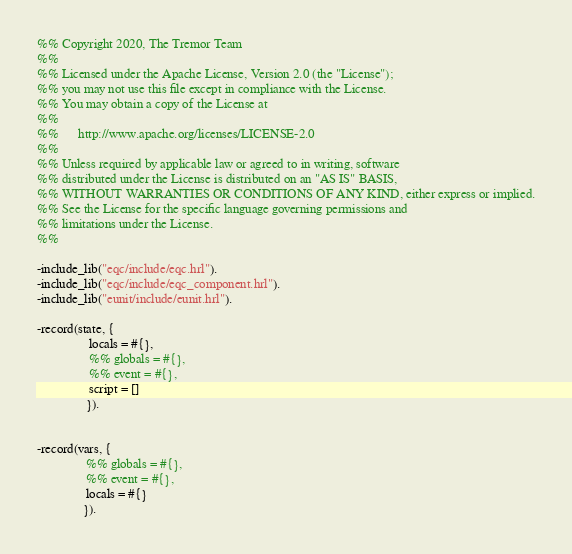<code> <loc_0><loc_0><loc_500><loc_500><_Erlang_>%% Copyright 2020, The Tremor Team
%%
%% Licensed under the Apache License, Version 2.0 (the "License");
%% you may not use this file except in compliance with the License.
%% You may obtain a copy of the License at
%%
%%      http://www.apache.org/licenses/LICENSE-2.0
%%
%% Unless required by applicable law or agreed to in writing, software
%% distributed under the License is distributed on an "AS IS" BASIS,
%% WITHOUT WARRANTIES OR CONDITIONS OF ANY KIND, either express or implied.
%% See the License for the specific language governing permissions and
%% limitations under the License.
%%

-include_lib("eqc/include/eqc.hrl").
-include_lib("eqc/include/eqc_component.hrl").
-include_lib("eunit/include/eunit.hrl").

-record(state, {
                locals = #{},
                %% globals = #{},
                %% event = #{},
                script = []
               }).


-record(vars, {
               %% globals = #{},
               %% event = #{},
               locals = #{}
              }).
</code> 